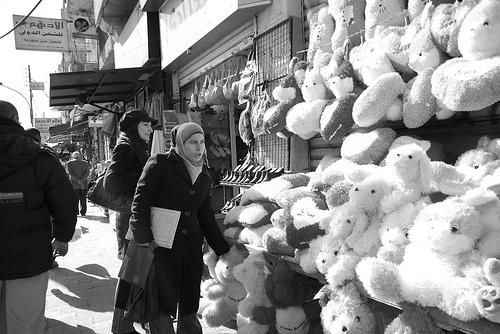Describe the sentiment or emotion conveyed by the subjects in the image. The image portrays a scene of shopping and interaction with stuffed animals, evoking a sense of curiosity and enjoyment. What is the woman wearing on her head, and what color is it? The woman is wearing a black hat. Name the different outfits and items in the image and their respective colors. Black coat, black hat, black jacket, white pants, black buttons on a garment, white teddy bear, brown teddy bear, and black shoes for sale. Assess the quality of the image based on the clarity of the provided image and object descriptions. The image quality is decent, as most of the image are clear and the object descriptions are mostly accurate in terms of their respective colors and positions. Count the number of teddy bears in the image and mention their colors. There are three teddy bears: one white, one brown, and one on the ground with an unspecified color. Mention an interaction between humans and objects in the image. A woman is touching a stuffed animal. Identify the color of the coat worn by the man in the image. The coat is black. Analyze the interaction between objects and subjects, and provide a possible context for the image. The context of the image might be a marketplace or a small shop, with people browsing and interacting with the objects, such as the stuffed animals and clothing items. How many people can be seen in the image, and what are they doing? There are four people: a man wearing a black coat with his hands behind his back, a woman touching a stuffed animal, and two women standing together. What kind of sign is mentioned in the image description, and what is written on it? It is a sign attached to a building with Arabic writing on it. Identify the activity of the man with a black coat and hands behind his back. Observing or browsing Are the shoes for sale located on a high shelf? This instruction is misleading because there's no information about the location of the shoes within the image aside from their coordinates, so we can't infer if they are on a high shelf or not. Is the book in the woman's hand? Yes Are the bags hanging from the eave of a building made from plastic and transparent? No, it's not mentioned in the image. Create a conversation between two women standing together at the market. Woman 1: "That white teddy bear over there is adorable." What type of objects are displayed in rows? Stuffed animals What color is the coat in the image? Black Highlight the objects on display at the market. Stuffed animals, clothing items like coats and hats, shoes, and bags. Describe the appearance of the woman touching the stuffed animal and her clothing. The woman is wearing a black hat, has a headscarf, and is actively engaging with a stuffed animal. What event is happening in the image, describe briefly. People are shopping at an outdoor market with various items for sale, such as teddy bears and clothing. Identify the activity of the woman touching a stuffed animal. Examining or shopping for a stuffed animal Is there any interaction between the shadows on the ground and the objects from the market? No direct interaction, but the shadows are cast by objects in the market and people walking around. Describe the teddy bear that is on the ground with its color and size. The teddy bear is large and white. What does the sign attached to the building say? Not clear or not visible List at least three kinds of items for sale at the marketplace. Coats, hats, shoes, bags, and teddy bears. What language is the writing on the sign? Arabic Is the shadow on the ground cast by a tall building next to the scene? The instruction is misleading because there's no information about what is causing the shadow on the ground, only that the shadow is present at the given coordinates. Describe the black hat present in the image. A black hat worn by a woman who is touching a stuffed animal. What is the setting of the image? An outdoor market Create a brief story that incorporates the white teddy bear, black hat, and woman touching a stuffed animal. A woman wearing a black hat spots a large white teddy bear in a crowded market. Intrigued, she walks closer and starts examining it with her hands, considering whether to buy it or not. Is there a person selling shoes in the image? Unclear or not visible Explain the layout of the image in a few words. People shopping in an outdoor market, with a variety of items for sale, such as teddy bears, clothing, and shoes. Can you confirm if the teddy bear on the ground is pink and tiny? The instruction is misleading because there are two teddy bears mentioned, and neither of them is described as pink or tiny. One is white, and the other is brown. 